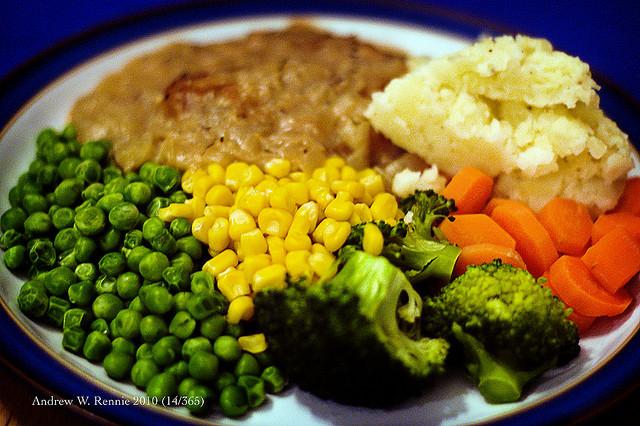Is this food in a bowl?
Give a very brief answer. No. What type of cup is that?
Write a very short answer. No cup. What is the yellow food?
Keep it brief. Corn. What vegetable is this?
Be succinct. Broccoli. Are there more vegetables than carbohydrates in the photo?
Answer briefly. Yes. What vegetable is on the left?
Quick response, please. Peas. What is in the picture?
Quick response, please. Food. Where are the corn?
Concise answer only. Middle. What is the brown food in the background?
Concise answer only. Gravy. Is this vegetable high in fiber?
Be succinct. Yes. What container is the vegetable medley in?
Keep it brief. Plate. 